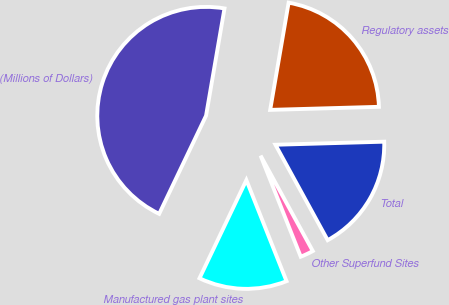Convert chart to OTSL. <chart><loc_0><loc_0><loc_500><loc_500><pie_chart><fcel>(Millions of Dollars)<fcel>Manufactured gas plant sites<fcel>Other Superfund Sites<fcel>Total<fcel>Regulatory assets<nl><fcel>45.62%<fcel>13.11%<fcel>1.95%<fcel>17.48%<fcel>21.84%<nl></chart> 